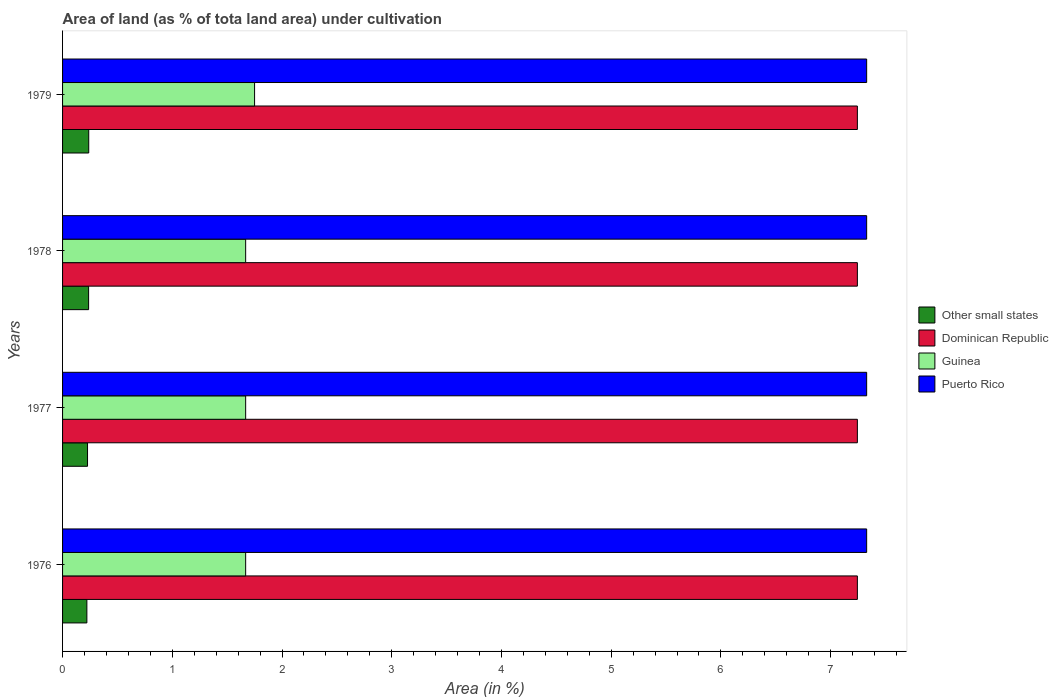How many different coloured bars are there?
Offer a terse response. 4. How many groups of bars are there?
Offer a terse response. 4. Are the number of bars on each tick of the Y-axis equal?
Ensure brevity in your answer.  Yes. How many bars are there on the 3rd tick from the bottom?
Your answer should be compact. 4. What is the label of the 2nd group of bars from the top?
Your answer should be compact. 1978. What is the percentage of land under cultivation in Other small states in 1978?
Your response must be concise. 0.24. Across all years, what is the maximum percentage of land under cultivation in Other small states?
Your answer should be compact. 0.24. Across all years, what is the minimum percentage of land under cultivation in Other small states?
Offer a very short reply. 0.22. In which year was the percentage of land under cultivation in Other small states maximum?
Offer a terse response. 1979. In which year was the percentage of land under cultivation in Guinea minimum?
Offer a very short reply. 1976. What is the total percentage of land under cultivation in Other small states in the graph?
Keep it short and to the point. 0.92. What is the difference between the percentage of land under cultivation in Puerto Rico in 1976 and that in 1978?
Keep it short and to the point. 0. What is the difference between the percentage of land under cultivation in Dominican Republic in 1979 and the percentage of land under cultivation in Other small states in 1977?
Make the answer very short. 7.02. What is the average percentage of land under cultivation in Other small states per year?
Ensure brevity in your answer.  0.23. In the year 1979, what is the difference between the percentage of land under cultivation in Other small states and percentage of land under cultivation in Guinea?
Offer a very short reply. -1.51. In how many years, is the percentage of land under cultivation in Puerto Rico greater than 4.8 %?
Make the answer very short. 4. What is the ratio of the percentage of land under cultivation in Puerto Rico in 1976 to that in 1977?
Your response must be concise. 1. Is the difference between the percentage of land under cultivation in Other small states in 1976 and 1977 greater than the difference between the percentage of land under cultivation in Guinea in 1976 and 1977?
Provide a succinct answer. No. What is the difference between the highest and the second highest percentage of land under cultivation in Dominican Republic?
Keep it short and to the point. 0. What is the difference between the highest and the lowest percentage of land under cultivation in Guinea?
Offer a terse response. 0.08. Is the sum of the percentage of land under cultivation in Guinea in 1976 and 1977 greater than the maximum percentage of land under cultivation in Dominican Republic across all years?
Offer a terse response. No. What does the 3rd bar from the top in 1979 represents?
Give a very brief answer. Dominican Republic. What does the 3rd bar from the bottom in 1977 represents?
Give a very brief answer. Guinea. Is it the case that in every year, the sum of the percentage of land under cultivation in Puerto Rico and percentage of land under cultivation in Dominican Republic is greater than the percentage of land under cultivation in Guinea?
Give a very brief answer. Yes. How many bars are there?
Give a very brief answer. 16. Are all the bars in the graph horizontal?
Your response must be concise. Yes. What is the difference between two consecutive major ticks on the X-axis?
Ensure brevity in your answer.  1. Where does the legend appear in the graph?
Your answer should be compact. Center right. How many legend labels are there?
Provide a short and direct response. 4. What is the title of the graph?
Provide a succinct answer. Area of land (as % of tota land area) under cultivation. What is the label or title of the X-axis?
Give a very brief answer. Area (in %). What is the label or title of the Y-axis?
Your answer should be compact. Years. What is the Area (in %) in Other small states in 1976?
Offer a terse response. 0.22. What is the Area (in %) in Dominican Republic in 1976?
Ensure brevity in your answer.  7.24. What is the Area (in %) in Guinea in 1976?
Your answer should be compact. 1.67. What is the Area (in %) of Puerto Rico in 1976?
Offer a very short reply. 7.33. What is the Area (in %) in Other small states in 1977?
Provide a short and direct response. 0.23. What is the Area (in %) in Dominican Republic in 1977?
Keep it short and to the point. 7.24. What is the Area (in %) in Guinea in 1977?
Make the answer very short. 1.67. What is the Area (in %) in Puerto Rico in 1977?
Provide a succinct answer. 7.33. What is the Area (in %) of Other small states in 1978?
Your response must be concise. 0.24. What is the Area (in %) of Dominican Republic in 1978?
Ensure brevity in your answer.  7.24. What is the Area (in %) of Guinea in 1978?
Make the answer very short. 1.67. What is the Area (in %) of Puerto Rico in 1978?
Provide a succinct answer. 7.33. What is the Area (in %) in Other small states in 1979?
Make the answer very short. 0.24. What is the Area (in %) of Dominican Republic in 1979?
Offer a terse response. 7.24. What is the Area (in %) in Guinea in 1979?
Provide a short and direct response. 1.75. What is the Area (in %) of Puerto Rico in 1979?
Your answer should be compact. 7.33. Across all years, what is the maximum Area (in %) of Other small states?
Ensure brevity in your answer.  0.24. Across all years, what is the maximum Area (in %) in Dominican Republic?
Ensure brevity in your answer.  7.24. Across all years, what is the maximum Area (in %) of Guinea?
Offer a terse response. 1.75. Across all years, what is the maximum Area (in %) of Puerto Rico?
Offer a very short reply. 7.33. Across all years, what is the minimum Area (in %) of Other small states?
Your answer should be very brief. 0.22. Across all years, what is the minimum Area (in %) in Dominican Republic?
Make the answer very short. 7.24. Across all years, what is the minimum Area (in %) in Guinea?
Your response must be concise. 1.67. Across all years, what is the minimum Area (in %) in Puerto Rico?
Provide a short and direct response. 7.33. What is the total Area (in %) of Other small states in the graph?
Make the answer very short. 0.92. What is the total Area (in %) of Dominican Republic in the graph?
Give a very brief answer. 28.97. What is the total Area (in %) in Guinea in the graph?
Make the answer very short. 6.76. What is the total Area (in %) of Puerto Rico in the graph?
Your answer should be compact. 29.31. What is the difference between the Area (in %) in Other small states in 1976 and that in 1977?
Make the answer very short. -0.01. What is the difference between the Area (in %) in Guinea in 1976 and that in 1977?
Provide a succinct answer. 0. What is the difference between the Area (in %) of Other small states in 1976 and that in 1978?
Provide a short and direct response. -0.02. What is the difference between the Area (in %) of Dominican Republic in 1976 and that in 1978?
Make the answer very short. 0. What is the difference between the Area (in %) in Puerto Rico in 1976 and that in 1978?
Make the answer very short. 0. What is the difference between the Area (in %) in Other small states in 1976 and that in 1979?
Give a very brief answer. -0.02. What is the difference between the Area (in %) of Dominican Republic in 1976 and that in 1979?
Provide a short and direct response. 0. What is the difference between the Area (in %) in Guinea in 1976 and that in 1979?
Give a very brief answer. -0.08. What is the difference between the Area (in %) of Other small states in 1977 and that in 1978?
Your answer should be compact. -0.01. What is the difference between the Area (in %) in Dominican Republic in 1977 and that in 1978?
Ensure brevity in your answer.  0. What is the difference between the Area (in %) in Guinea in 1977 and that in 1978?
Your answer should be compact. 0. What is the difference between the Area (in %) of Puerto Rico in 1977 and that in 1978?
Offer a very short reply. 0. What is the difference between the Area (in %) in Other small states in 1977 and that in 1979?
Make the answer very short. -0.01. What is the difference between the Area (in %) of Dominican Republic in 1977 and that in 1979?
Keep it short and to the point. 0. What is the difference between the Area (in %) of Guinea in 1977 and that in 1979?
Provide a succinct answer. -0.08. What is the difference between the Area (in %) of Puerto Rico in 1977 and that in 1979?
Ensure brevity in your answer.  0. What is the difference between the Area (in %) in Other small states in 1978 and that in 1979?
Keep it short and to the point. -0. What is the difference between the Area (in %) of Guinea in 1978 and that in 1979?
Your response must be concise. -0.08. What is the difference between the Area (in %) in Puerto Rico in 1978 and that in 1979?
Give a very brief answer. 0. What is the difference between the Area (in %) in Other small states in 1976 and the Area (in %) in Dominican Republic in 1977?
Your answer should be compact. -7.02. What is the difference between the Area (in %) of Other small states in 1976 and the Area (in %) of Guinea in 1977?
Your response must be concise. -1.45. What is the difference between the Area (in %) in Other small states in 1976 and the Area (in %) in Puerto Rico in 1977?
Your answer should be compact. -7.11. What is the difference between the Area (in %) in Dominican Republic in 1976 and the Area (in %) in Guinea in 1977?
Provide a short and direct response. 5.57. What is the difference between the Area (in %) of Dominican Republic in 1976 and the Area (in %) of Puerto Rico in 1977?
Ensure brevity in your answer.  -0.08. What is the difference between the Area (in %) in Guinea in 1976 and the Area (in %) in Puerto Rico in 1977?
Provide a short and direct response. -5.66. What is the difference between the Area (in %) in Other small states in 1976 and the Area (in %) in Dominican Republic in 1978?
Offer a terse response. -7.02. What is the difference between the Area (in %) of Other small states in 1976 and the Area (in %) of Guinea in 1978?
Make the answer very short. -1.45. What is the difference between the Area (in %) of Other small states in 1976 and the Area (in %) of Puerto Rico in 1978?
Your answer should be compact. -7.11. What is the difference between the Area (in %) of Dominican Republic in 1976 and the Area (in %) of Guinea in 1978?
Keep it short and to the point. 5.57. What is the difference between the Area (in %) in Dominican Republic in 1976 and the Area (in %) in Puerto Rico in 1978?
Your response must be concise. -0.08. What is the difference between the Area (in %) in Guinea in 1976 and the Area (in %) in Puerto Rico in 1978?
Offer a very short reply. -5.66. What is the difference between the Area (in %) in Other small states in 1976 and the Area (in %) in Dominican Republic in 1979?
Your answer should be very brief. -7.02. What is the difference between the Area (in %) in Other small states in 1976 and the Area (in %) in Guinea in 1979?
Provide a succinct answer. -1.53. What is the difference between the Area (in %) in Other small states in 1976 and the Area (in %) in Puerto Rico in 1979?
Offer a very short reply. -7.11. What is the difference between the Area (in %) of Dominican Republic in 1976 and the Area (in %) of Guinea in 1979?
Provide a succinct answer. 5.49. What is the difference between the Area (in %) of Dominican Republic in 1976 and the Area (in %) of Puerto Rico in 1979?
Ensure brevity in your answer.  -0.08. What is the difference between the Area (in %) of Guinea in 1976 and the Area (in %) of Puerto Rico in 1979?
Offer a very short reply. -5.66. What is the difference between the Area (in %) of Other small states in 1977 and the Area (in %) of Dominican Republic in 1978?
Provide a short and direct response. -7.02. What is the difference between the Area (in %) in Other small states in 1977 and the Area (in %) in Guinea in 1978?
Provide a succinct answer. -1.44. What is the difference between the Area (in %) in Other small states in 1977 and the Area (in %) in Puerto Rico in 1978?
Offer a terse response. -7.1. What is the difference between the Area (in %) of Dominican Republic in 1977 and the Area (in %) of Guinea in 1978?
Make the answer very short. 5.57. What is the difference between the Area (in %) of Dominican Republic in 1977 and the Area (in %) of Puerto Rico in 1978?
Offer a terse response. -0.08. What is the difference between the Area (in %) in Guinea in 1977 and the Area (in %) in Puerto Rico in 1978?
Offer a very short reply. -5.66. What is the difference between the Area (in %) of Other small states in 1977 and the Area (in %) of Dominican Republic in 1979?
Offer a very short reply. -7.02. What is the difference between the Area (in %) of Other small states in 1977 and the Area (in %) of Guinea in 1979?
Ensure brevity in your answer.  -1.52. What is the difference between the Area (in %) in Other small states in 1977 and the Area (in %) in Puerto Rico in 1979?
Your response must be concise. -7.1. What is the difference between the Area (in %) in Dominican Republic in 1977 and the Area (in %) in Guinea in 1979?
Your answer should be compact. 5.49. What is the difference between the Area (in %) in Dominican Republic in 1977 and the Area (in %) in Puerto Rico in 1979?
Offer a very short reply. -0.08. What is the difference between the Area (in %) in Guinea in 1977 and the Area (in %) in Puerto Rico in 1979?
Offer a very short reply. -5.66. What is the difference between the Area (in %) in Other small states in 1978 and the Area (in %) in Dominican Republic in 1979?
Provide a succinct answer. -7.01. What is the difference between the Area (in %) in Other small states in 1978 and the Area (in %) in Guinea in 1979?
Keep it short and to the point. -1.51. What is the difference between the Area (in %) of Other small states in 1978 and the Area (in %) of Puerto Rico in 1979?
Make the answer very short. -7.09. What is the difference between the Area (in %) of Dominican Republic in 1978 and the Area (in %) of Guinea in 1979?
Keep it short and to the point. 5.49. What is the difference between the Area (in %) in Dominican Republic in 1978 and the Area (in %) in Puerto Rico in 1979?
Your response must be concise. -0.08. What is the difference between the Area (in %) of Guinea in 1978 and the Area (in %) of Puerto Rico in 1979?
Offer a very short reply. -5.66. What is the average Area (in %) in Other small states per year?
Your answer should be very brief. 0.23. What is the average Area (in %) of Dominican Republic per year?
Your response must be concise. 7.24. What is the average Area (in %) in Guinea per year?
Make the answer very short. 1.69. What is the average Area (in %) in Puerto Rico per year?
Provide a short and direct response. 7.33. In the year 1976, what is the difference between the Area (in %) in Other small states and Area (in %) in Dominican Republic?
Provide a short and direct response. -7.02. In the year 1976, what is the difference between the Area (in %) of Other small states and Area (in %) of Guinea?
Give a very brief answer. -1.45. In the year 1976, what is the difference between the Area (in %) in Other small states and Area (in %) in Puerto Rico?
Provide a short and direct response. -7.11. In the year 1976, what is the difference between the Area (in %) in Dominican Republic and Area (in %) in Guinea?
Ensure brevity in your answer.  5.57. In the year 1976, what is the difference between the Area (in %) in Dominican Republic and Area (in %) in Puerto Rico?
Make the answer very short. -0.08. In the year 1976, what is the difference between the Area (in %) in Guinea and Area (in %) in Puerto Rico?
Offer a very short reply. -5.66. In the year 1977, what is the difference between the Area (in %) in Other small states and Area (in %) in Dominican Republic?
Keep it short and to the point. -7.02. In the year 1977, what is the difference between the Area (in %) of Other small states and Area (in %) of Guinea?
Make the answer very short. -1.44. In the year 1977, what is the difference between the Area (in %) of Other small states and Area (in %) of Puerto Rico?
Provide a short and direct response. -7.1. In the year 1977, what is the difference between the Area (in %) of Dominican Republic and Area (in %) of Guinea?
Offer a terse response. 5.57. In the year 1977, what is the difference between the Area (in %) in Dominican Republic and Area (in %) in Puerto Rico?
Your answer should be compact. -0.08. In the year 1977, what is the difference between the Area (in %) of Guinea and Area (in %) of Puerto Rico?
Provide a short and direct response. -5.66. In the year 1978, what is the difference between the Area (in %) in Other small states and Area (in %) in Dominican Republic?
Provide a succinct answer. -7.01. In the year 1978, what is the difference between the Area (in %) of Other small states and Area (in %) of Guinea?
Offer a very short reply. -1.43. In the year 1978, what is the difference between the Area (in %) of Other small states and Area (in %) of Puerto Rico?
Keep it short and to the point. -7.09. In the year 1978, what is the difference between the Area (in %) of Dominican Republic and Area (in %) of Guinea?
Your answer should be very brief. 5.57. In the year 1978, what is the difference between the Area (in %) of Dominican Republic and Area (in %) of Puerto Rico?
Provide a succinct answer. -0.08. In the year 1978, what is the difference between the Area (in %) in Guinea and Area (in %) in Puerto Rico?
Provide a short and direct response. -5.66. In the year 1979, what is the difference between the Area (in %) in Other small states and Area (in %) in Dominican Republic?
Provide a succinct answer. -7. In the year 1979, what is the difference between the Area (in %) of Other small states and Area (in %) of Guinea?
Your answer should be compact. -1.51. In the year 1979, what is the difference between the Area (in %) in Other small states and Area (in %) in Puerto Rico?
Your response must be concise. -7.09. In the year 1979, what is the difference between the Area (in %) of Dominican Republic and Area (in %) of Guinea?
Make the answer very short. 5.49. In the year 1979, what is the difference between the Area (in %) in Dominican Republic and Area (in %) in Puerto Rico?
Ensure brevity in your answer.  -0.08. In the year 1979, what is the difference between the Area (in %) in Guinea and Area (in %) in Puerto Rico?
Give a very brief answer. -5.58. What is the ratio of the Area (in %) in Other small states in 1976 to that in 1977?
Give a very brief answer. 0.97. What is the ratio of the Area (in %) in Dominican Republic in 1976 to that in 1977?
Offer a terse response. 1. What is the ratio of the Area (in %) of Guinea in 1976 to that in 1977?
Provide a short and direct response. 1. What is the ratio of the Area (in %) of Puerto Rico in 1976 to that in 1977?
Keep it short and to the point. 1. What is the ratio of the Area (in %) in Other small states in 1976 to that in 1979?
Give a very brief answer. 0.93. What is the ratio of the Area (in %) in Guinea in 1976 to that in 1979?
Provide a short and direct response. 0.95. What is the ratio of the Area (in %) of Puerto Rico in 1976 to that in 1979?
Your answer should be very brief. 1. What is the ratio of the Area (in %) of Other small states in 1977 to that in 1978?
Provide a short and direct response. 0.96. What is the ratio of the Area (in %) of Dominican Republic in 1977 to that in 1978?
Give a very brief answer. 1. What is the ratio of the Area (in %) in Puerto Rico in 1977 to that in 1978?
Provide a succinct answer. 1. What is the ratio of the Area (in %) in Other small states in 1977 to that in 1979?
Give a very brief answer. 0.95. What is the ratio of the Area (in %) in Guinea in 1977 to that in 1979?
Give a very brief answer. 0.95. What is the ratio of the Area (in %) of Guinea in 1978 to that in 1979?
Your answer should be compact. 0.95. What is the ratio of the Area (in %) of Puerto Rico in 1978 to that in 1979?
Your answer should be compact. 1. What is the difference between the highest and the second highest Area (in %) of Other small states?
Offer a very short reply. 0. What is the difference between the highest and the second highest Area (in %) of Dominican Republic?
Keep it short and to the point. 0. What is the difference between the highest and the second highest Area (in %) in Guinea?
Offer a terse response. 0.08. What is the difference between the highest and the lowest Area (in %) of Other small states?
Your answer should be very brief. 0.02. What is the difference between the highest and the lowest Area (in %) of Guinea?
Keep it short and to the point. 0.08. 